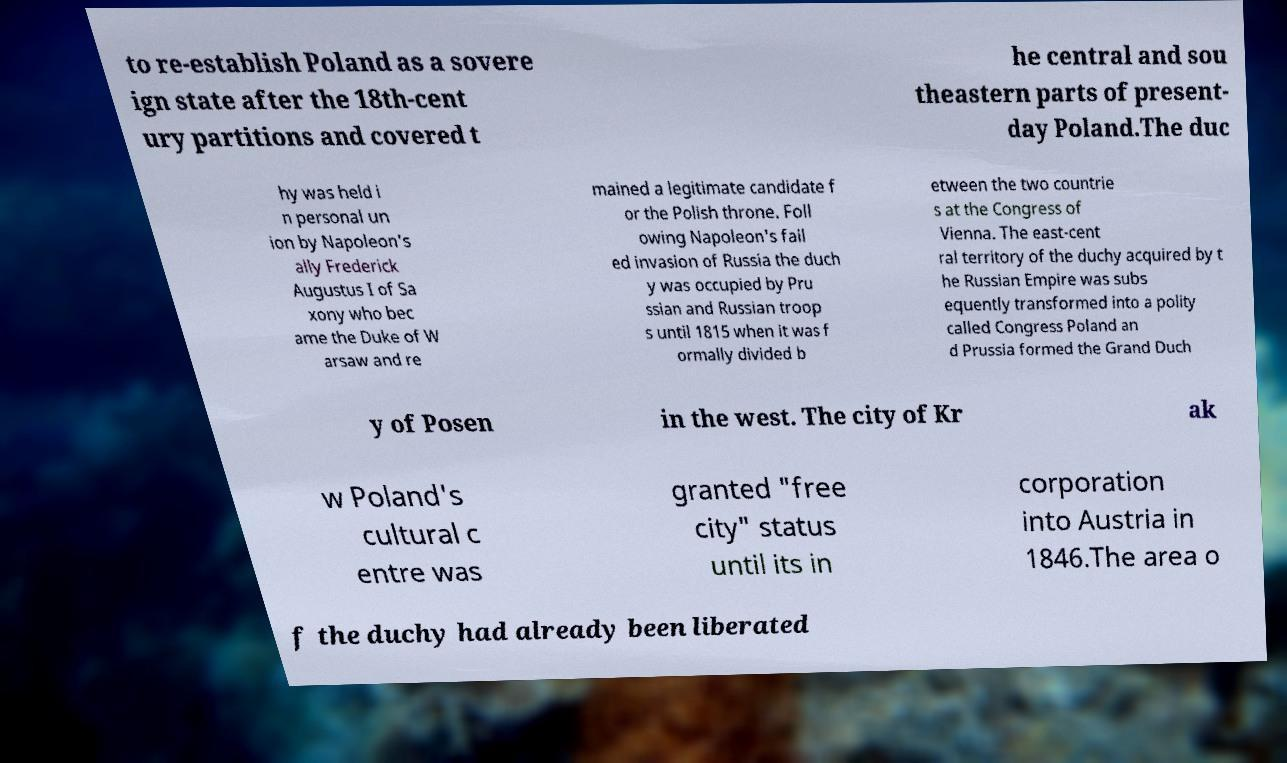Please read and relay the text visible in this image. What does it say? to re-establish Poland as a sovere ign state after the 18th-cent ury partitions and covered t he central and sou theastern parts of present- day Poland.The duc hy was held i n personal un ion by Napoleon's ally Frederick Augustus I of Sa xony who bec ame the Duke of W arsaw and re mained a legitimate candidate f or the Polish throne. Foll owing Napoleon's fail ed invasion of Russia the duch y was occupied by Pru ssian and Russian troop s until 1815 when it was f ormally divided b etween the two countrie s at the Congress of Vienna. The east-cent ral territory of the duchy acquired by t he Russian Empire was subs equently transformed into a polity called Congress Poland an d Prussia formed the Grand Duch y of Posen in the west. The city of Kr ak w Poland's cultural c entre was granted "free city" status until its in corporation into Austria in 1846.The area o f the duchy had already been liberated 